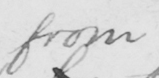Can you tell me what this handwritten text says? from 